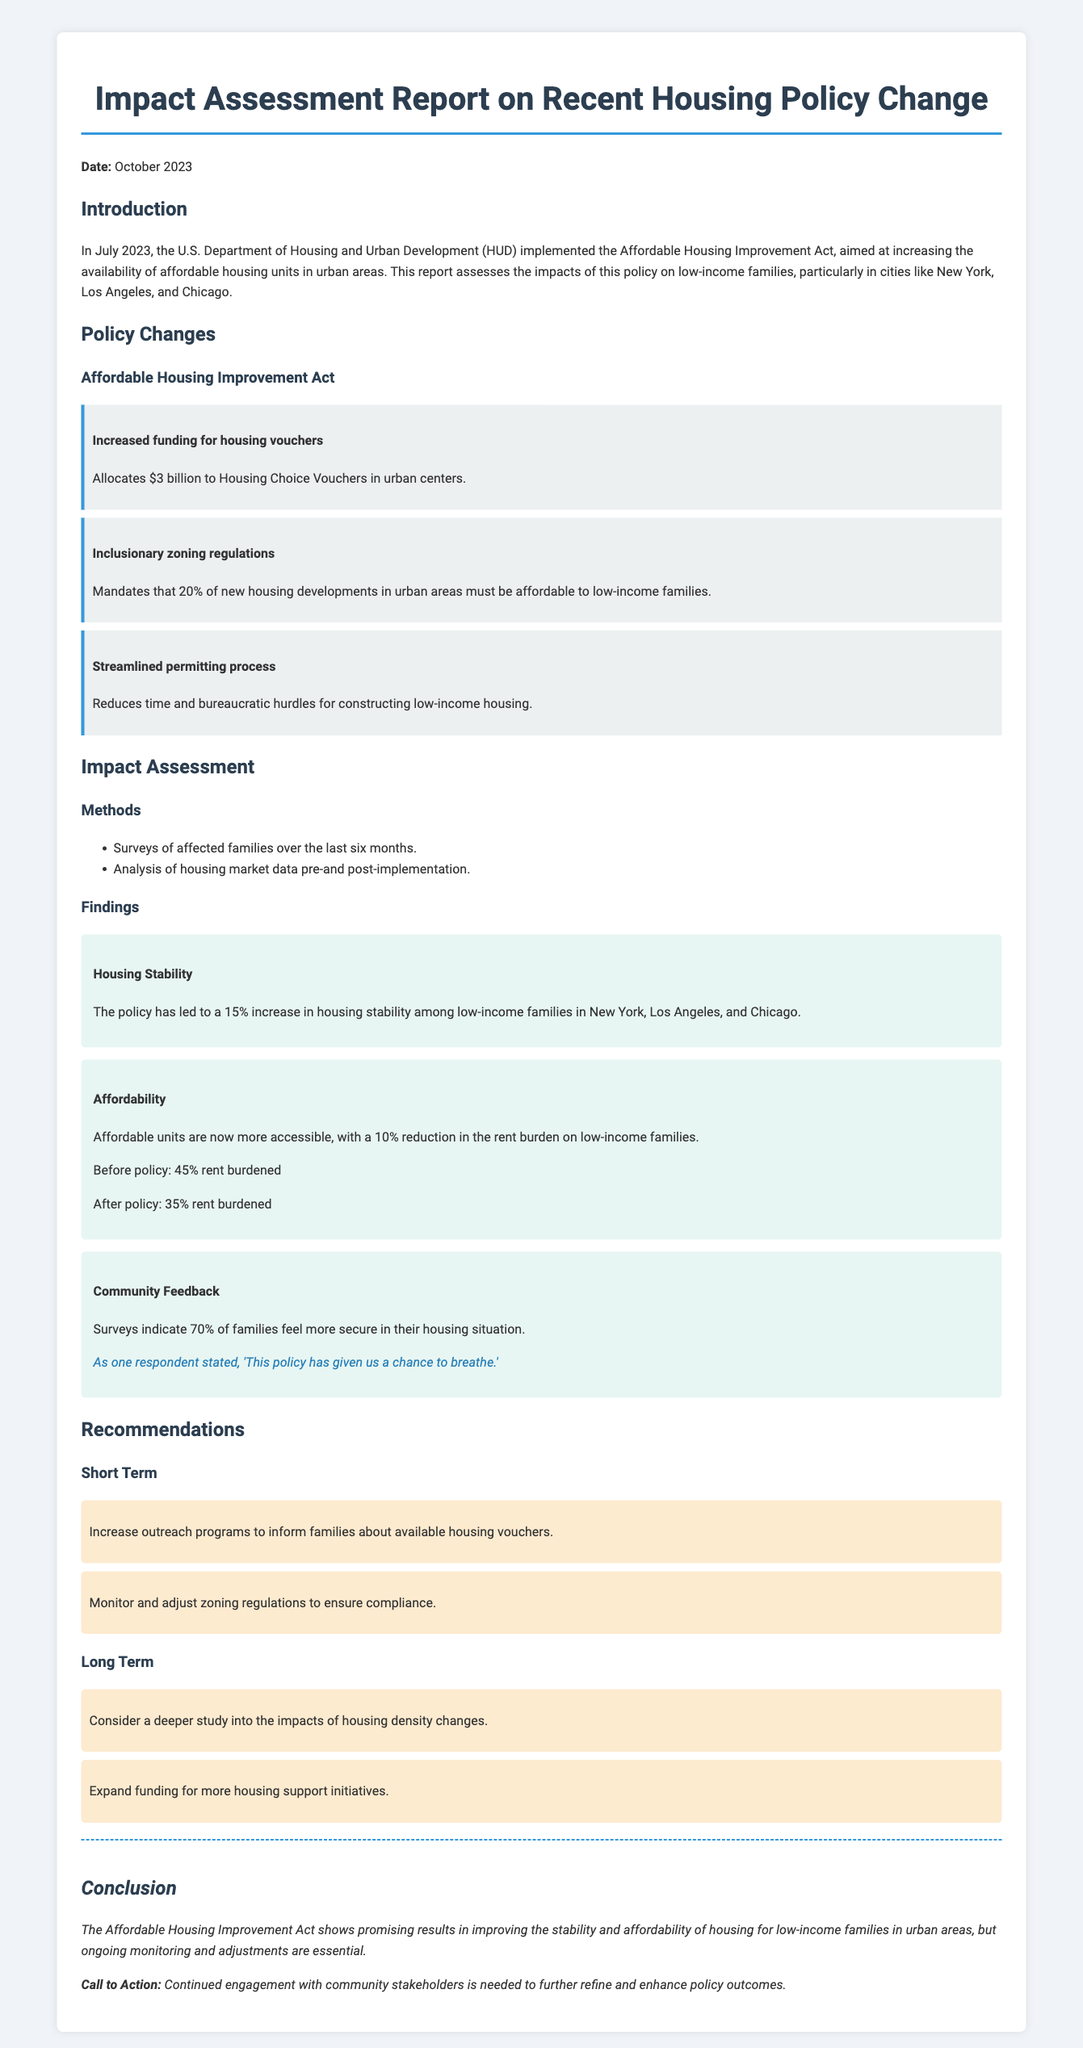What is the title of the report? The title is the main heading of the document that summarizes its focus, which is "Impact Assessment Report on Recent Housing Policy Change."
Answer: Impact Assessment Report on Recent Housing Policy Change When was the policy implemented? The date of implementation is provided in the introduction section of the document.
Answer: July 2023 How much funding was allocated to housing vouchers? The specific funding amount is mentioned in the section detailing policy changes.
Answer: $3 billion What percentage of new housing developments must be affordable? The requirement is stated in the inclusionary zoning regulations within the policy changes.
Answer: 20% What is the percentage increase in housing stability? This figure is found in the findings section regarding housing stability among low-income families.
Answer: 15% What was the reduction in the rent burden after the policy? The change in rent burden is detailed in the affordability finding, comparing before and after the policy.
Answer: 10% What percentage of families feel more secure in their housing situation? This statistic is provided as part of the community feedback findings.
Answer: 70% What type of study is recommended for the long term? The recommendation section includes a mention of a deeper study into a specific area.
Answer: Impacts of housing density changes 